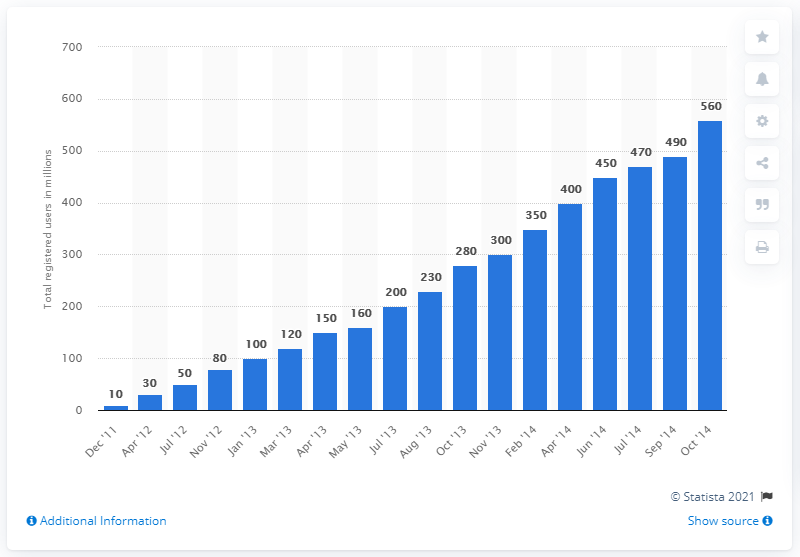Highlight a few significant elements in this photo. In April 2014, the number of registered users of LINE was approximately 400. As of October 2014, LINE had approximately 560 million users worldwide. 